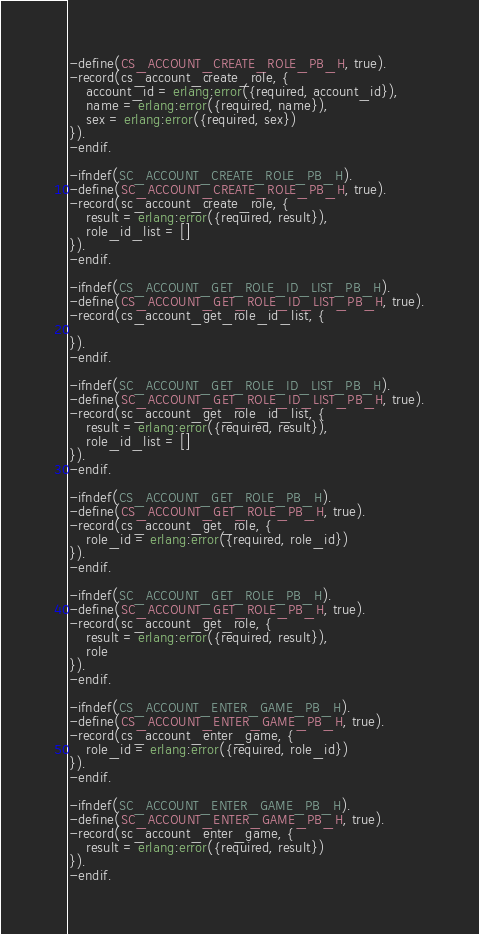<code> <loc_0><loc_0><loc_500><loc_500><_Erlang_>-define(CS_ACCOUNT_CREATE_ROLE_PB_H, true).
-record(cs_account_create_role, {
    account_id = erlang:error({required, account_id}),
    name = erlang:error({required, name}),
    sex = erlang:error({required, sex})
}).
-endif.

-ifndef(SC_ACCOUNT_CREATE_ROLE_PB_H).
-define(SC_ACCOUNT_CREATE_ROLE_PB_H, true).
-record(sc_account_create_role, {
    result = erlang:error({required, result}),
    role_id_list = []
}).
-endif.

-ifndef(CS_ACCOUNT_GET_ROLE_ID_LIST_PB_H).
-define(CS_ACCOUNT_GET_ROLE_ID_LIST_PB_H, true).
-record(cs_account_get_role_id_list, {
    
}).
-endif.

-ifndef(SC_ACCOUNT_GET_ROLE_ID_LIST_PB_H).
-define(SC_ACCOUNT_GET_ROLE_ID_LIST_PB_H, true).
-record(sc_account_get_role_id_list, {
    result = erlang:error({required, result}),
    role_id_list = []
}).
-endif.

-ifndef(CS_ACCOUNT_GET_ROLE_PB_H).
-define(CS_ACCOUNT_GET_ROLE_PB_H, true).
-record(cs_account_get_role, {
    role_id = erlang:error({required, role_id})
}).
-endif.

-ifndef(SC_ACCOUNT_GET_ROLE_PB_H).
-define(SC_ACCOUNT_GET_ROLE_PB_H, true).
-record(sc_account_get_role, {
    result = erlang:error({required, result}),
    role
}).
-endif.

-ifndef(CS_ACCOUNT_ENTER_GAME_PB_H).
-define(CS_ACCOUNT_ENTER_GAME_PB_H, true).
-record(cs_account_enter_game, {
    role_id = erlang:error({required, role_id})
}).
-endif.

-ifndef(SC_ACCOUNT_ENTER_GAME_PB_H).
-define(SC_ACCOUNT_ENTER_GAME_PB_H, true).
-record(sc_account_enter_game, {
    result = erlang:error({required, result})
}).
-endif.

</code> 